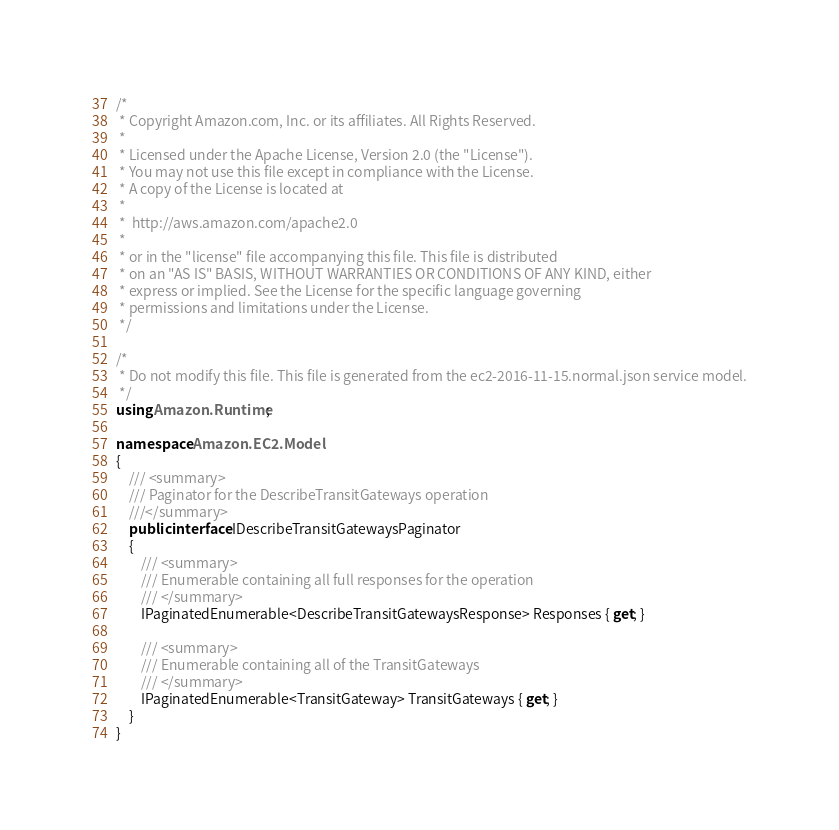<code> <loc_0><loc_0><loc_500><loc_500><_C#_>/*
 * Copyright Amazon.com, Inc. or its affiliates. All Rights Reserved.
 * 
 * Licensed under the Apache License, Version 2.0 (the "License").
 * You may not use this file except in compliance with the License.
 * A copy of the License is located at
 * 
 *  http://aws.amazon.com/apache2.0
 * 
 * or in the "license" file accompanying this file. This file is distributed
 * on an "AS IS" BASIS, WITHOUT WARRANTIES OR CONDITIONS OF ANY KIND, either
 * express or implied. See the License for the specific language governing
 * permissions and limitations under the License.
 */

/*
 * Do not modify this file. This file is generated from the ec2-2016-11-15.normal.json service model.
 */
using Amazon.Runtime;

namespace Amazon.EC2.Model
{
    /// <summary>
    /// Paginator for the DescribeTransitGateways operation
    ///</summary>
    public interface IDescribeTransitGatewaysPaginator
    {
        /// <summary>
        /// Enumerable containing all full responses for the operation
        /// </summary>
        IPaginatedEnumerable<DescribeTransitGatewaysResponse> Responses { get; }

        /// <summary>
        /// Enumerable containing all of the TransitGateways
        /// </summary>
        IPaginatedEnumerable<TransitGateway> TransitGateways { get; }
    }
}</code> 